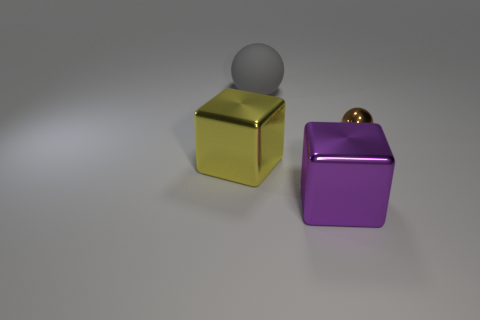What number of things are both to the left of the large purple metallic cube and behind the large yellow object?
Give a very brief answer. 1. How many cylinders are small metallic things or yellow things?
Offer a very short reply. 0. Are there any small spheres?
Your answer should be compact. Yes. How many other things are made of the same material as the tiny object?
Your answer should be very brief. 2. There is a purple cube that is the same size as the yellow metallic cube; what is its material?
Ensure brevity in your answer.  Metal. There is a small brown object right of the large yellow metal cube; does it have the same shape as the large gray matte object?
Provide a short and direct response. Yes. Does the tiny shiny thing have the same color as the large sphere?
Offer a terse response. No. What number of things are either blocks that are on the left side of the big ball or blue balls?
Keep it short and to the point. 1. What is the shape of the purple thing that is the same size as the gray rubber ball?
Make the answer very short. Cube. There is a thing that is in front of the large yellow cube; is its size the same as the ball behind the tiny metallic sphere?
Provide a succinct answer. Yes. 